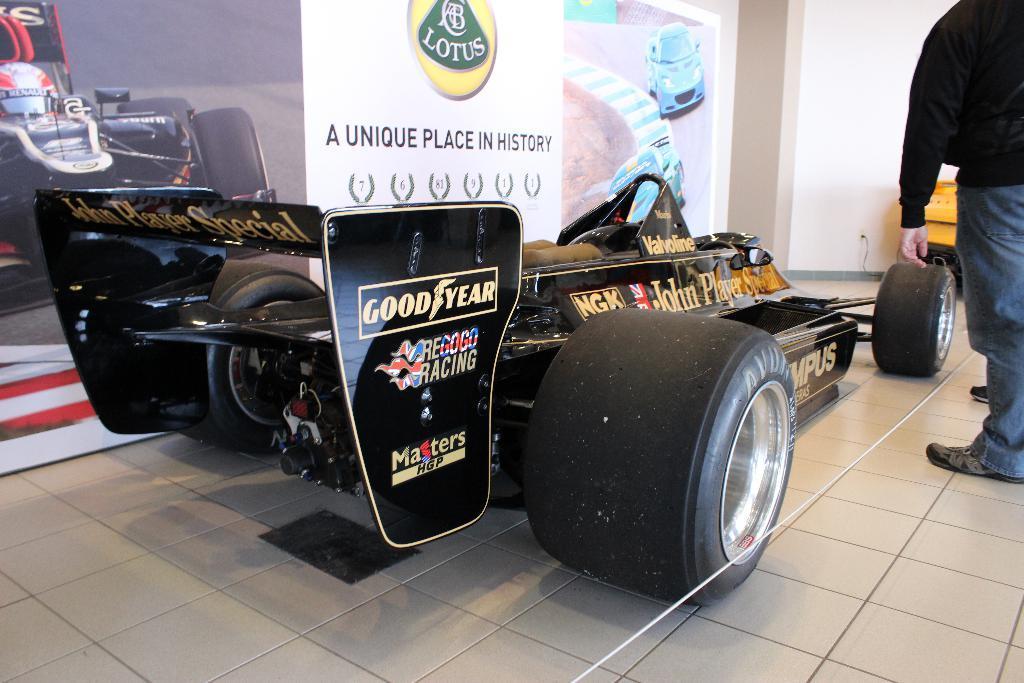Could you give a brief overview of what you see in this image? In this picture we can see a vehicle and a man standing on the floor, posters and in the background we can see an object and the wall. 